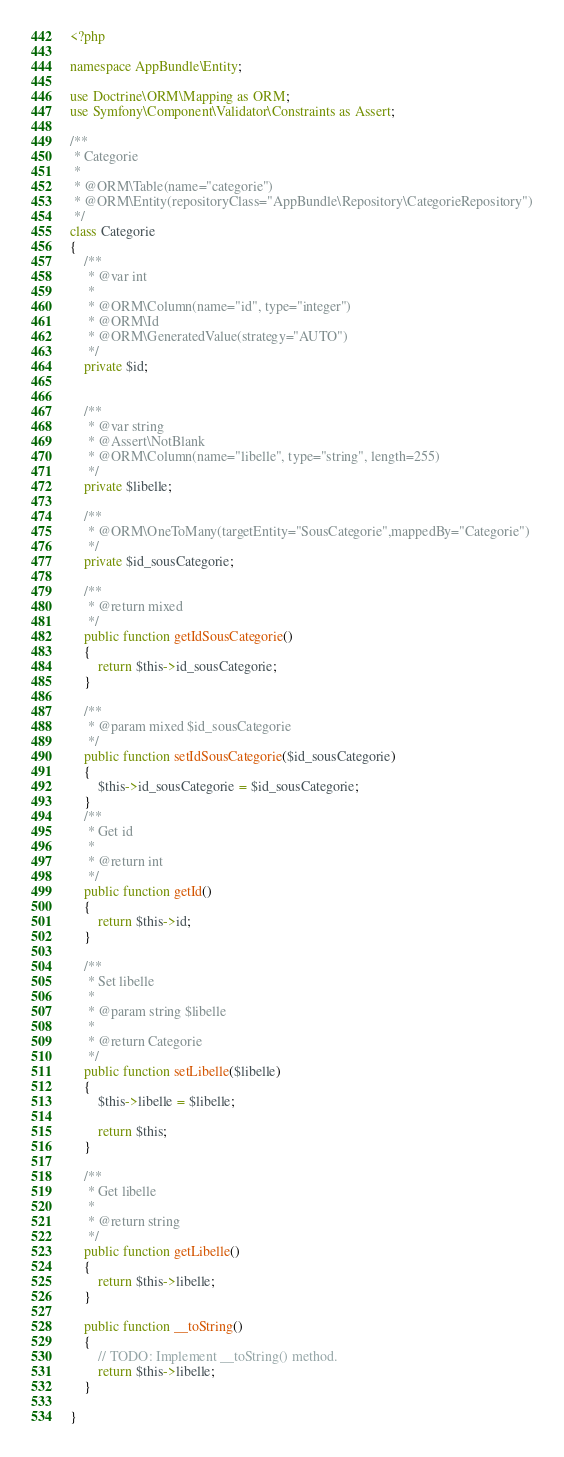<code> <loc_0><loc_0><loc_500><loc_500><_PHP_><?php

namespace AppBundle\Entity;

use Doctrine\ORM\Mapping as ORM;
use Symfony\Component\Validator\Constraints as Assert;

/**
 * Categorie
 *
 * @ORM\Table(name="categorie")
 * @ORM\Entity(repositoryClass="AppBundle\Repository\CategorieRepository")
 */
class Categorie
{
    /**
     * @var int
     *
     * @ORM\Column(name="id", type="integer")
     * @ORM\Id
     * @ORM\GeneratedValue(strategy="AUTO")
     */
    private $id;


    /**
     * @var string
     * @Assert\NotBlank
     * @ORM\Column(name="libelle", type="string", length=255)
     */
    private $libelle;

    /**
     * @ORM\OneToMany(targetEntity="SousCategorie",mappedBy="Categorie")
     */
    private $id_sousCategorie;

    /**
     * @return mixed
     */
    public function getIdSousCategorie()
    {
        return $this->id_sousCategorie;
    }

    /**
     * @param mixed $id_sousCategorie
     */
    public function setIdSousCategorie($id_sousCategorie)
    {
        $this->id_sousCategorie = $id_sousCategorie;
    }
    /**
     * Get id
     *
     * @return int
     */
    public function getId()
    {
        return $this->id;
    }

    /**
     * Set libelle
     *
     * @param string $libelle
     *
     * @return Categorie
     */
    public function setLibelle($libelle)
    {
        $this->libelle = $libelle;

        return $this;
    }

    /**
     * Get libelle
     *
     * @return string
     */
    public function getLibelle()
    {
        return $this->libelle;
    }

    public function __toString()
    {
        // TODO: Implement __toString() method.
        return $this->libelle;
    }

}

</code> 